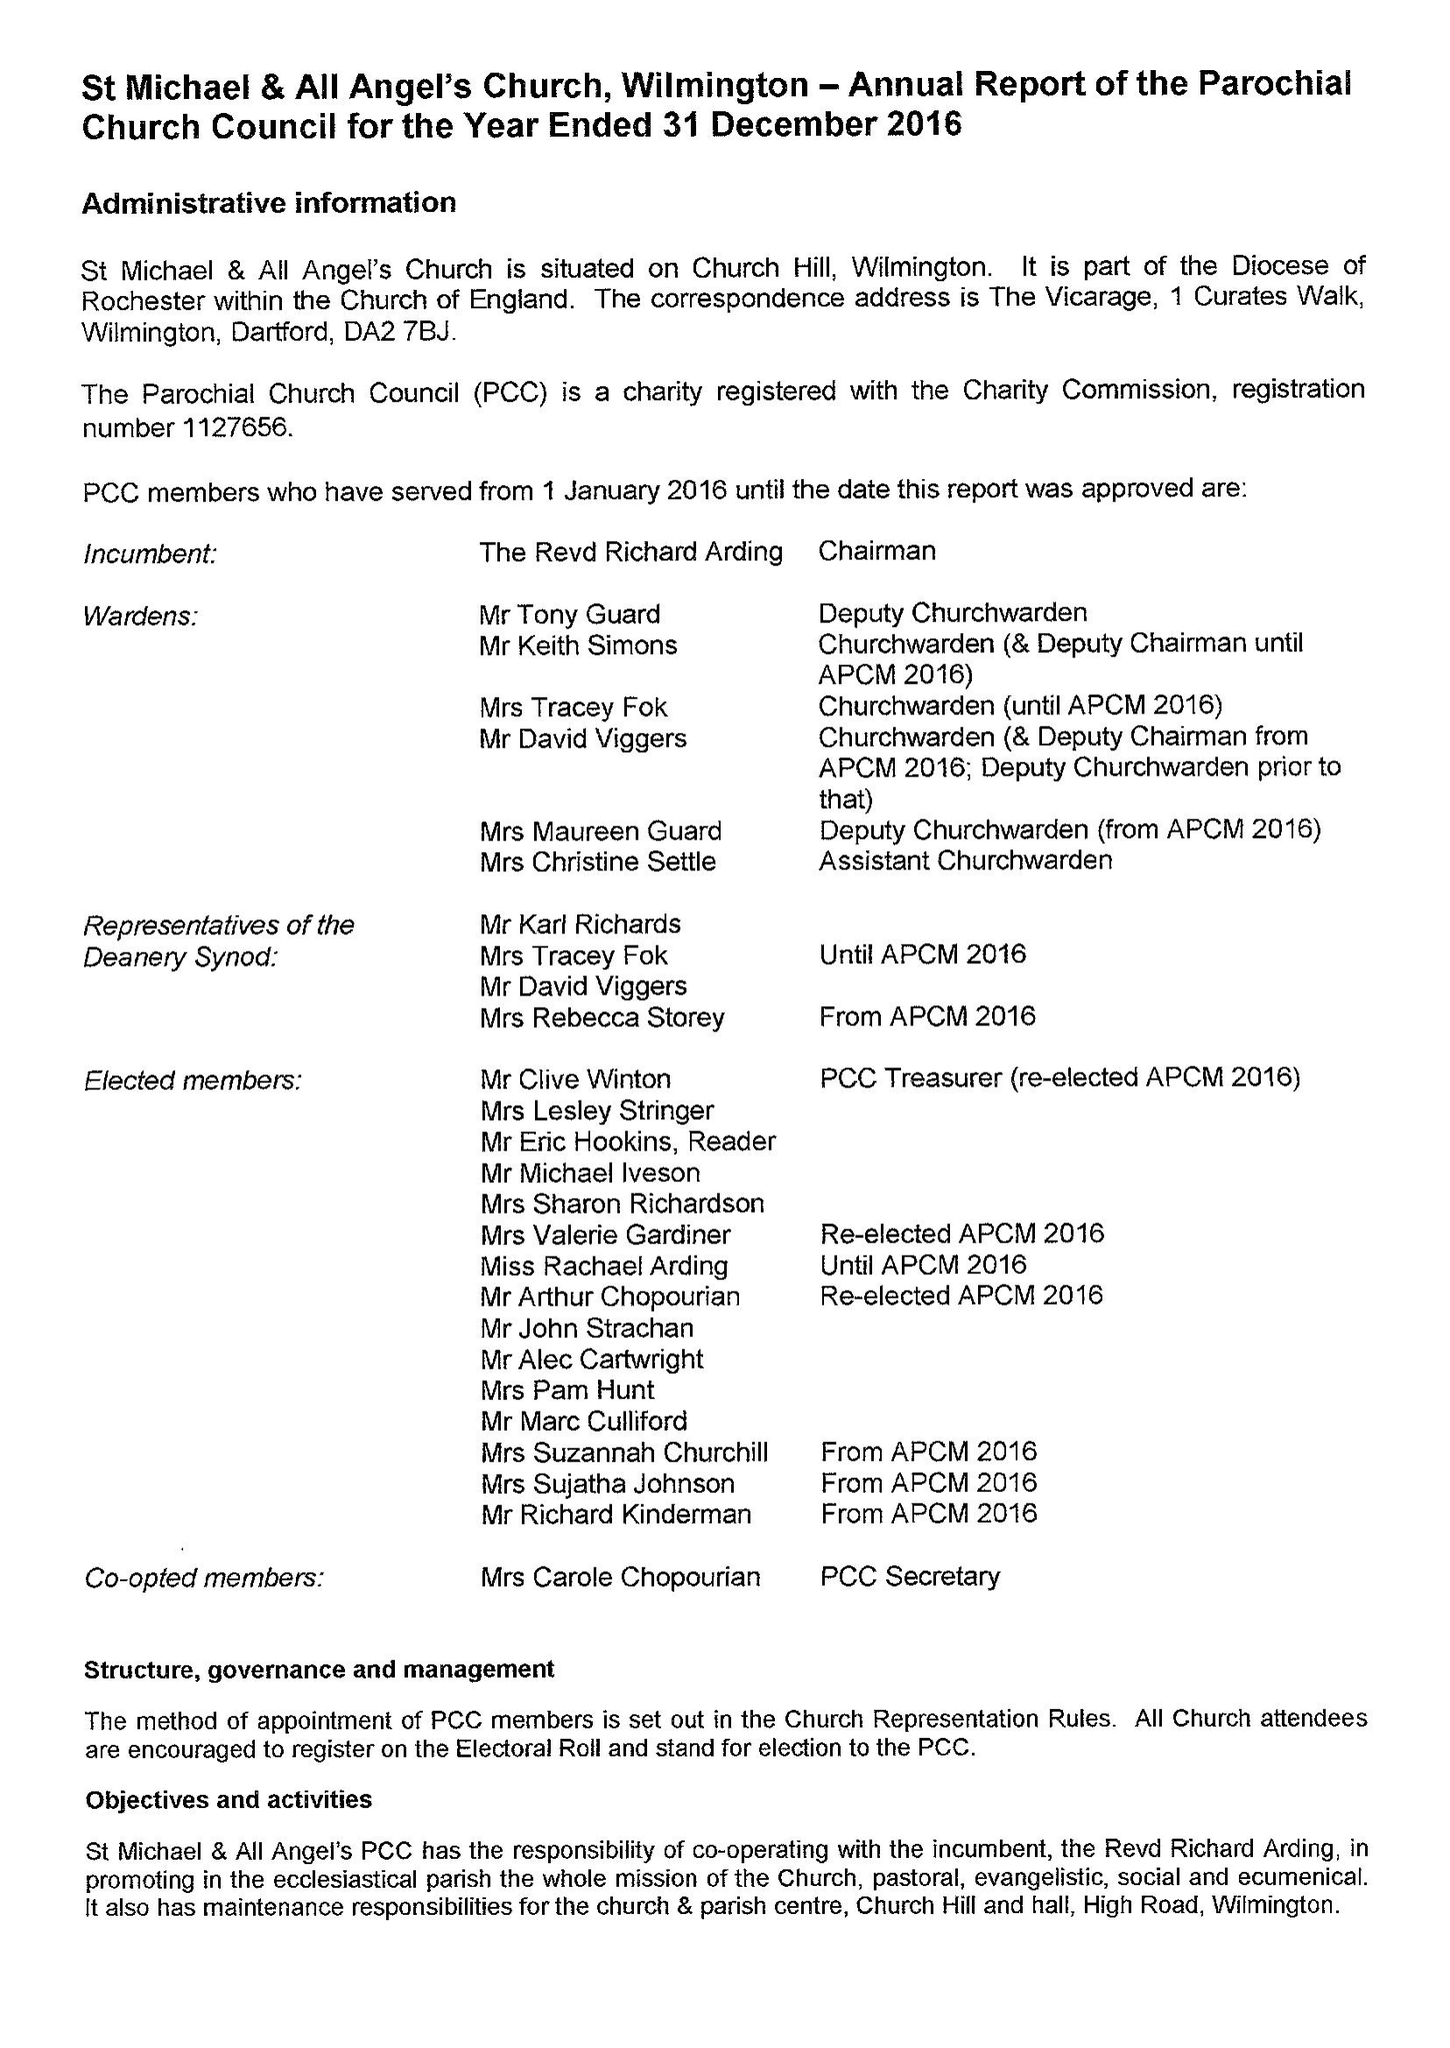What is the value for the report_date?
Answer the question using a single word or phrase. 2016-12-31 